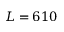<formula> <loc_0><loc_0><loc_500><loc_500>L = 6 1 0</formula> 